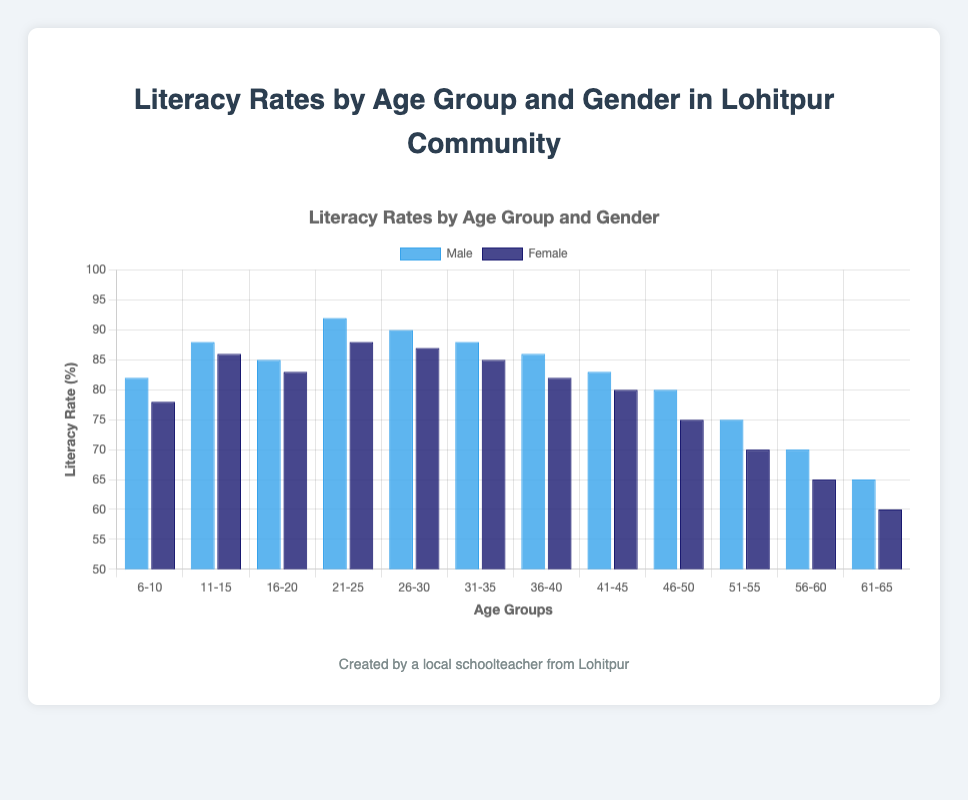What is the literacy rate for females in the age group 6-10? Look at the chart, find the bar labeled "6-10" for females, and check the height of the bar which represents the literacy rate.
Answer: 78 How does the literacy rate for females in the age group 21-25 compare to males in the same group? Compare the heights of the bars labeled "21-25" for both males and females.
Answer: Females: 88, Males: 92 Which age group has the highest literacy rate for males? Look for the tallest bar in the male category across all age groups.
Answer: 21-25 What is the average literacy rate for females across all age groups? Sum the literacy rates for females across all age groups (78 + 86 + 83 + 88 + 87 + 85 + 82 + 80 + 75 + 70 + 65 + 60) and divide by the number of age groups (12).
Answer: 78.25 What's the difference in literacy rates between males and females in the age group 46-50? Subtract the literacy rate of females from that of males in the age group 46-50.
Answer: 5 In which age group is the literacy rate gap between males and females the smallest? Calculate the difference in literacy rates between males and females for each age group and find the smallest value.
Answer: 31-35 (3) Which age group shows the most significant decline in literacy rates for both genders as they age? Compare the differences in literacy rates between successive age groups for both genders and identify the age group with the most significant decline.
Answer: 46-50 to 51-55 What is the literacy rate for males ages 56-60? Look at the chart and find the bar labeled "56-60" for males, then check the height of the bar representing the literacy rate.
Answer: 70 How much higher is the literacy rate for males compared to females in the age group 11-15? Subtract the literacy rate of females from that of males in the age group 11-15.
Answer: 2 How do the literacy rates for males and females in the age group 16-20 compare to those in the age group 21-25? Compare the literacy rates of males and females in the age group 16-20 to those in the age group 21-25 for both genders to see the increase or decrease.
Answer: Males: 16-20: 85, 21-25: 92 (increase: 7); Females: 16-20: 83, 21-25: 88 (increase: 5) 